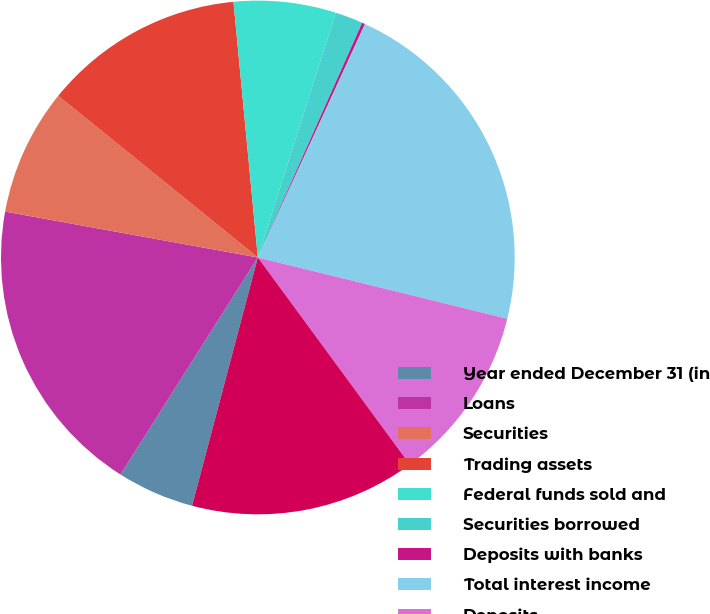<chart> <loc_0><loc_0><loc_500><loc_500><pie_chart><fcel>Year ended December 31 (in<fcel>Loans<fcel>Securities<fcel>Trading assets<fcel>Federal funds sold and<fcel>Securities borrowed<fcel>Deposits with banks<fcel>Total interest income<fcel>Deposits<fcel>Short-term and other<nl><fcel>4.86%<fcel>18.88%<fcel>7.98%<fcel>12.65%<fcel>6.42%<fcel>1.75%<fcel>0.19%<fcel>21.99%<fcel>11.09%<fcel>14.2%<nl></chart> 